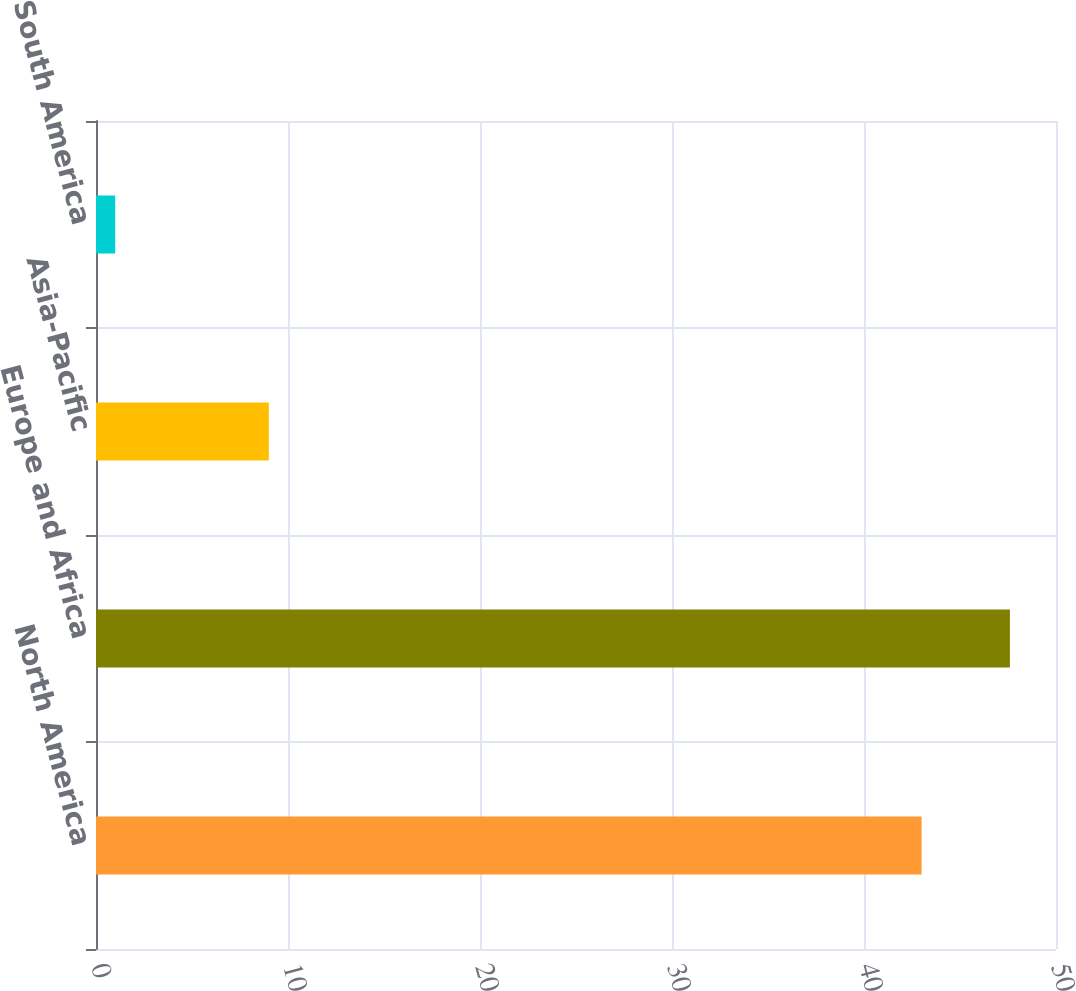Convert chart. <chart><loc_0><loc_0><loc_500><loc_500><bar_chart><fcel>North America<fcel>Europe and Africa<fcel>Asia-Pacific<fcel>South America<nl><fcel>43<fcel>47.6<fcel>9<fcel>1<nl></chart> 